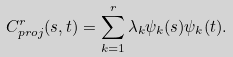Convert formula to latex. <formula><loc_0><loc_0><loc_500><loc_500>C _ { p r o j } ^ { r } ( s , t ) = \sum _ { k = 1 } ^ { r } \lambda _ { k } \psi _ { k } ( s ) \psi _ { k } ( t ) .</formula> 